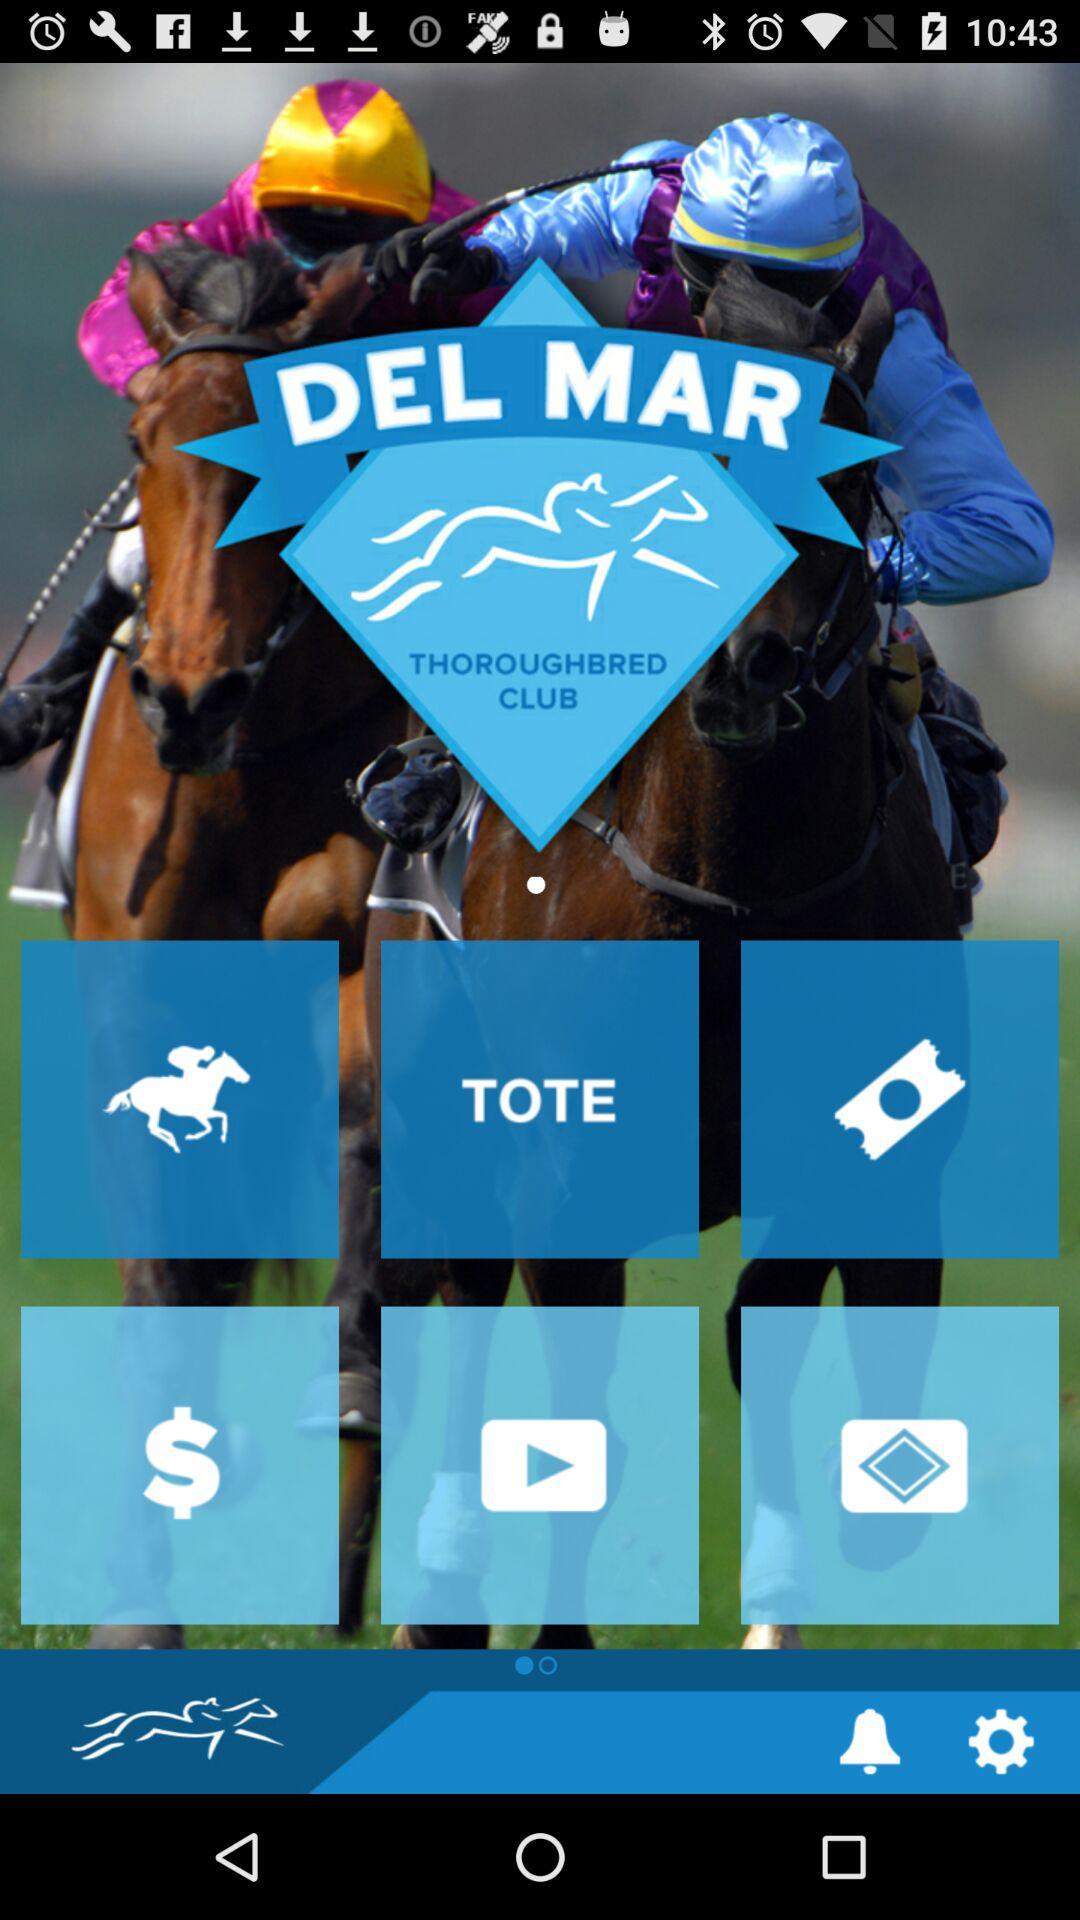What is the name of the club? The name of the club is "THOROUGHBRED". 